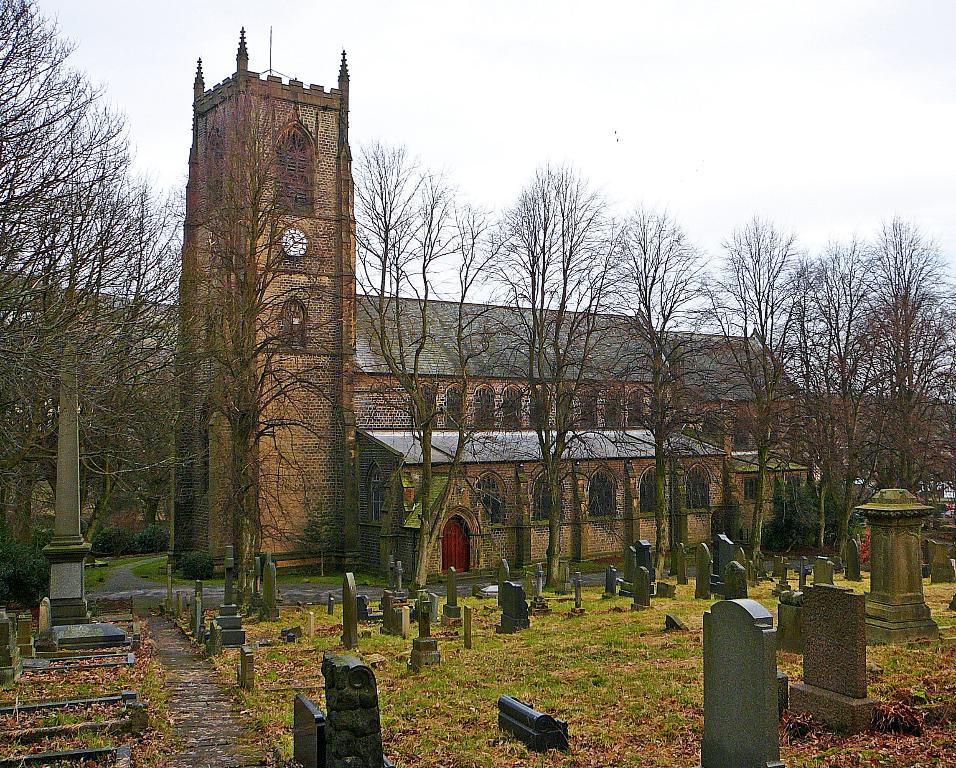Could you give a brief overview of what you see in this image? In this image in front there are statues. At the bottom of the image there is grass on the surface. In the background there are buildings, trees and sky. 